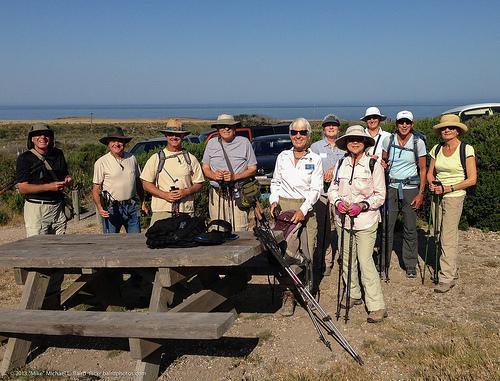How many people are there?
Give a very brief answer. 10. 